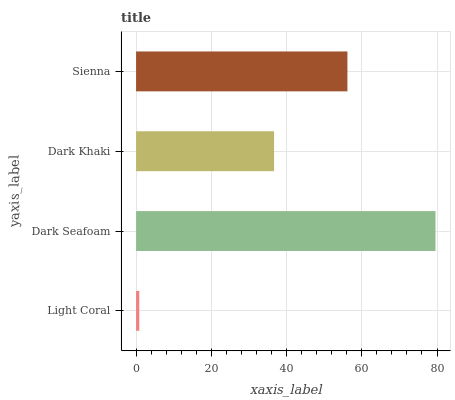Is Light Coral the minimum?
Answer yes or no. Yes. Is Dark Seafoam the maximum?
Answer yes or no. Yes. Is Dark Khaki the minimum?
Answer yes or no. No. Is Dark Khaki the maximum?
Answer yes or no. No. Is Dark Seafoam greater than Dark Khaki?
Answer yes or no. Yes. Is Dark Khaki less than Dark Seafoam?
Answer yes or no. Yes. Is Dark Khaki greater than Dark Seafoam?
Answer yes or no. No. Is Dark Seafoam less than Dark Khaki?
Answer yes or no. No. Is Sienna the high median?
Answer yes or no. Yes. Is Dark Khaki the low median?
Answer yes or no. Yes. Is Dark Khaki the high median?
Answer yes or no. No. Is Dark Seafoam the low median?
Answer yes or no. No. 